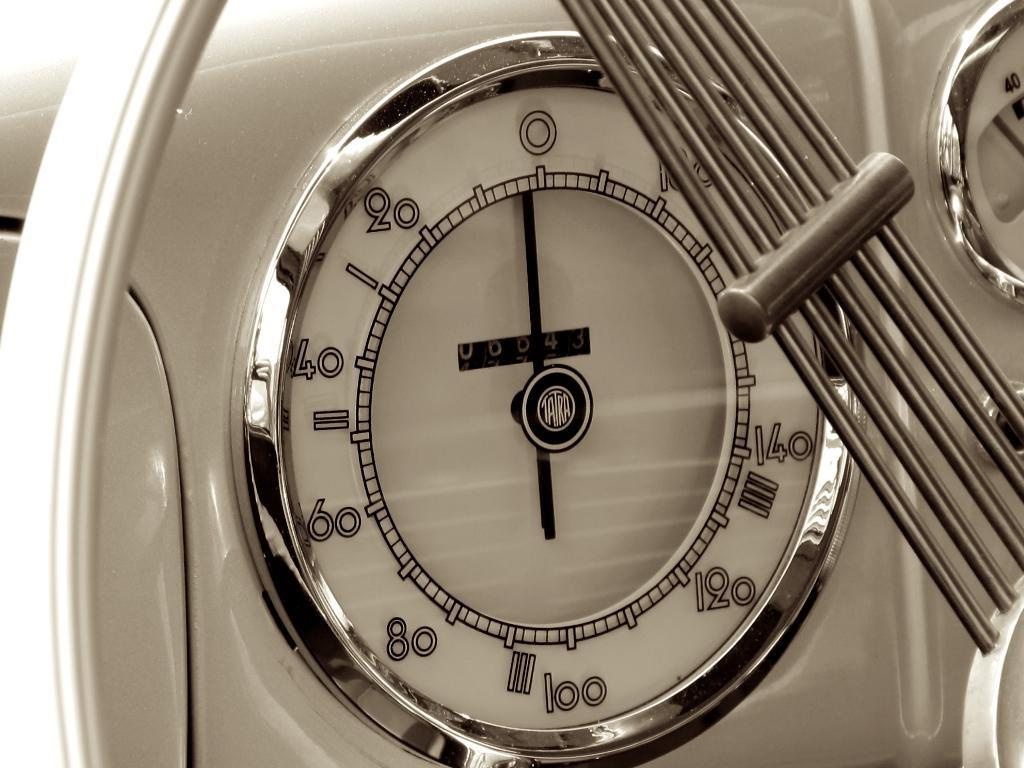<image>
Relay a brief, clear account of the picture shown. A white speed gauge for a Tatra is currently at zero. 